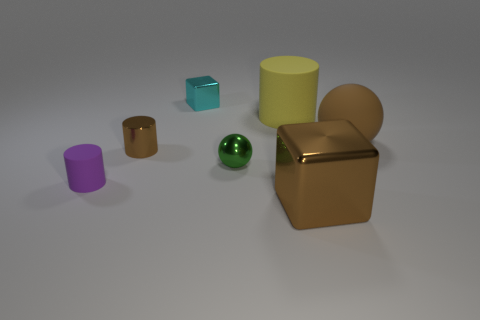How do these objects appear in terms of lighting and shadows? The lighting in the image comes from the upper left, casting soft shadows on the right side of the objects. The intensity of the shadows varies, suggesting a diffused light source that creates a subtle transition from light to dark across the scene. 